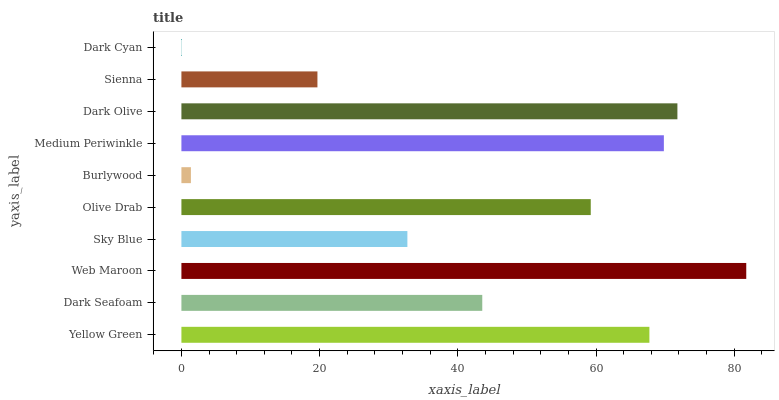Is Dark Cyan the minimum?
Answer yes or no. Yes. Is Web Maroon the maximum?
Answer yes or no. Yes. Is Dark Seafoam the minimum?
Answer yes or no. No. Is Dark Seafoam the maximum?
Answer yes or no. No. Is Yellow Green greater than Dark Seafoam?
Answer yes or no. Yes. Is Dark Seafoam less than Yellow Green?
Answer yes or no. Yes. Is Dark Seafoam greater than Yellow Green?
Answer yes or no. No. Is Yellow Green less than Dark Seafoam?
Answer yes or no. No. Is Olive Drab the high median?
Answer yes or no. Yes. Is Dark Seafoam the low median?
Answer yes or no. Yes. Is Burlywood the high median?
Answer yes or no. No. Is Sienna the low median?
Answer yes or no. No. 